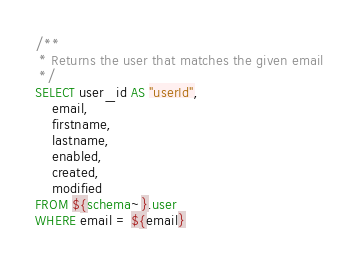Convert code to text. <code><loc_0><loc_0><loc_500><loc_500><_SQL_>/**
 * Returns the user that matches the given email
 */
SELECT user_id AS "userId",
    email,
    firstname,
    lastname,
    enabled,
    created,
    modified
FROM ${schema~}.user
WHERE email = ${email}
</code> 